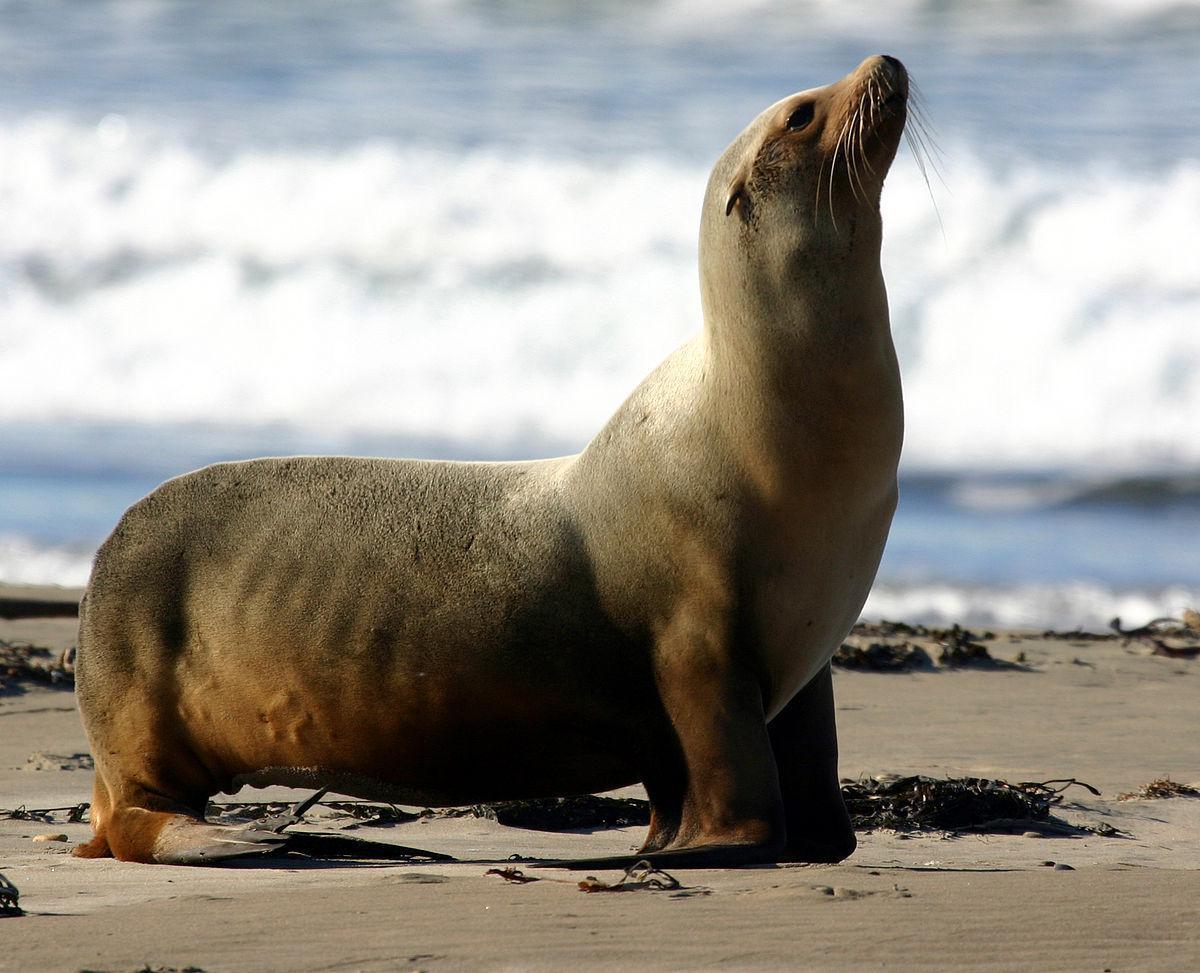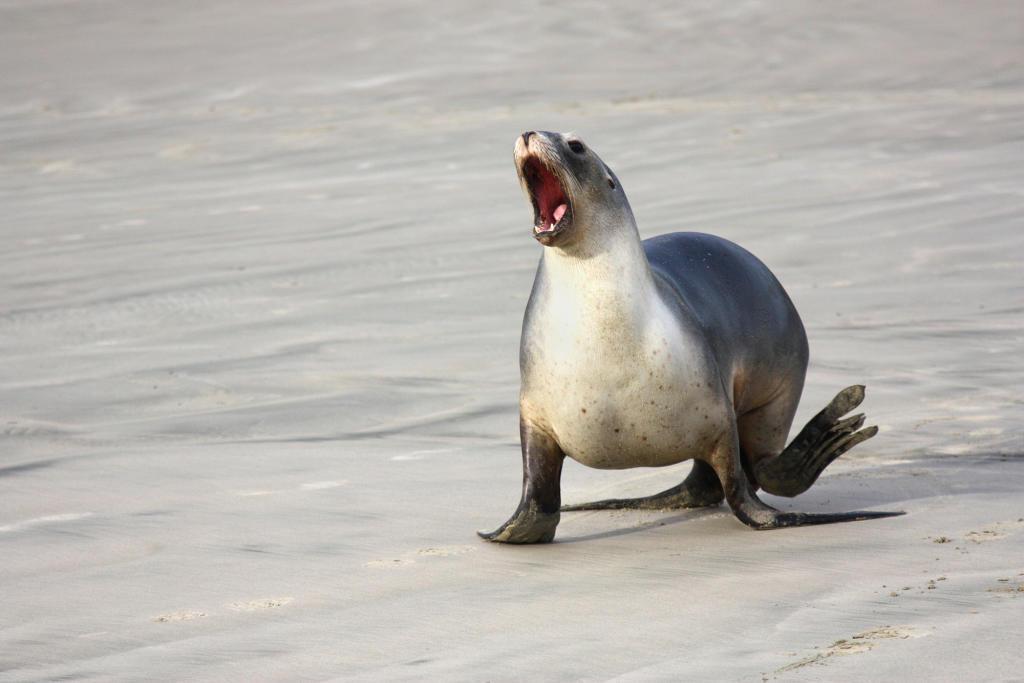The first image is the image on the left, the second image is the image on the right. Considering the images on both sides, is "The right image shows a seal and no other animal, posed on smooth rock in front of blue-green water." valid? Answer yes or no. No. The first image is the image on the left, the second image is the image on the right. For the images displayed, is the sentence "A single wet seal is sunning on a rock alone in the image on the right." factually correct? Answer yes or no. No. 